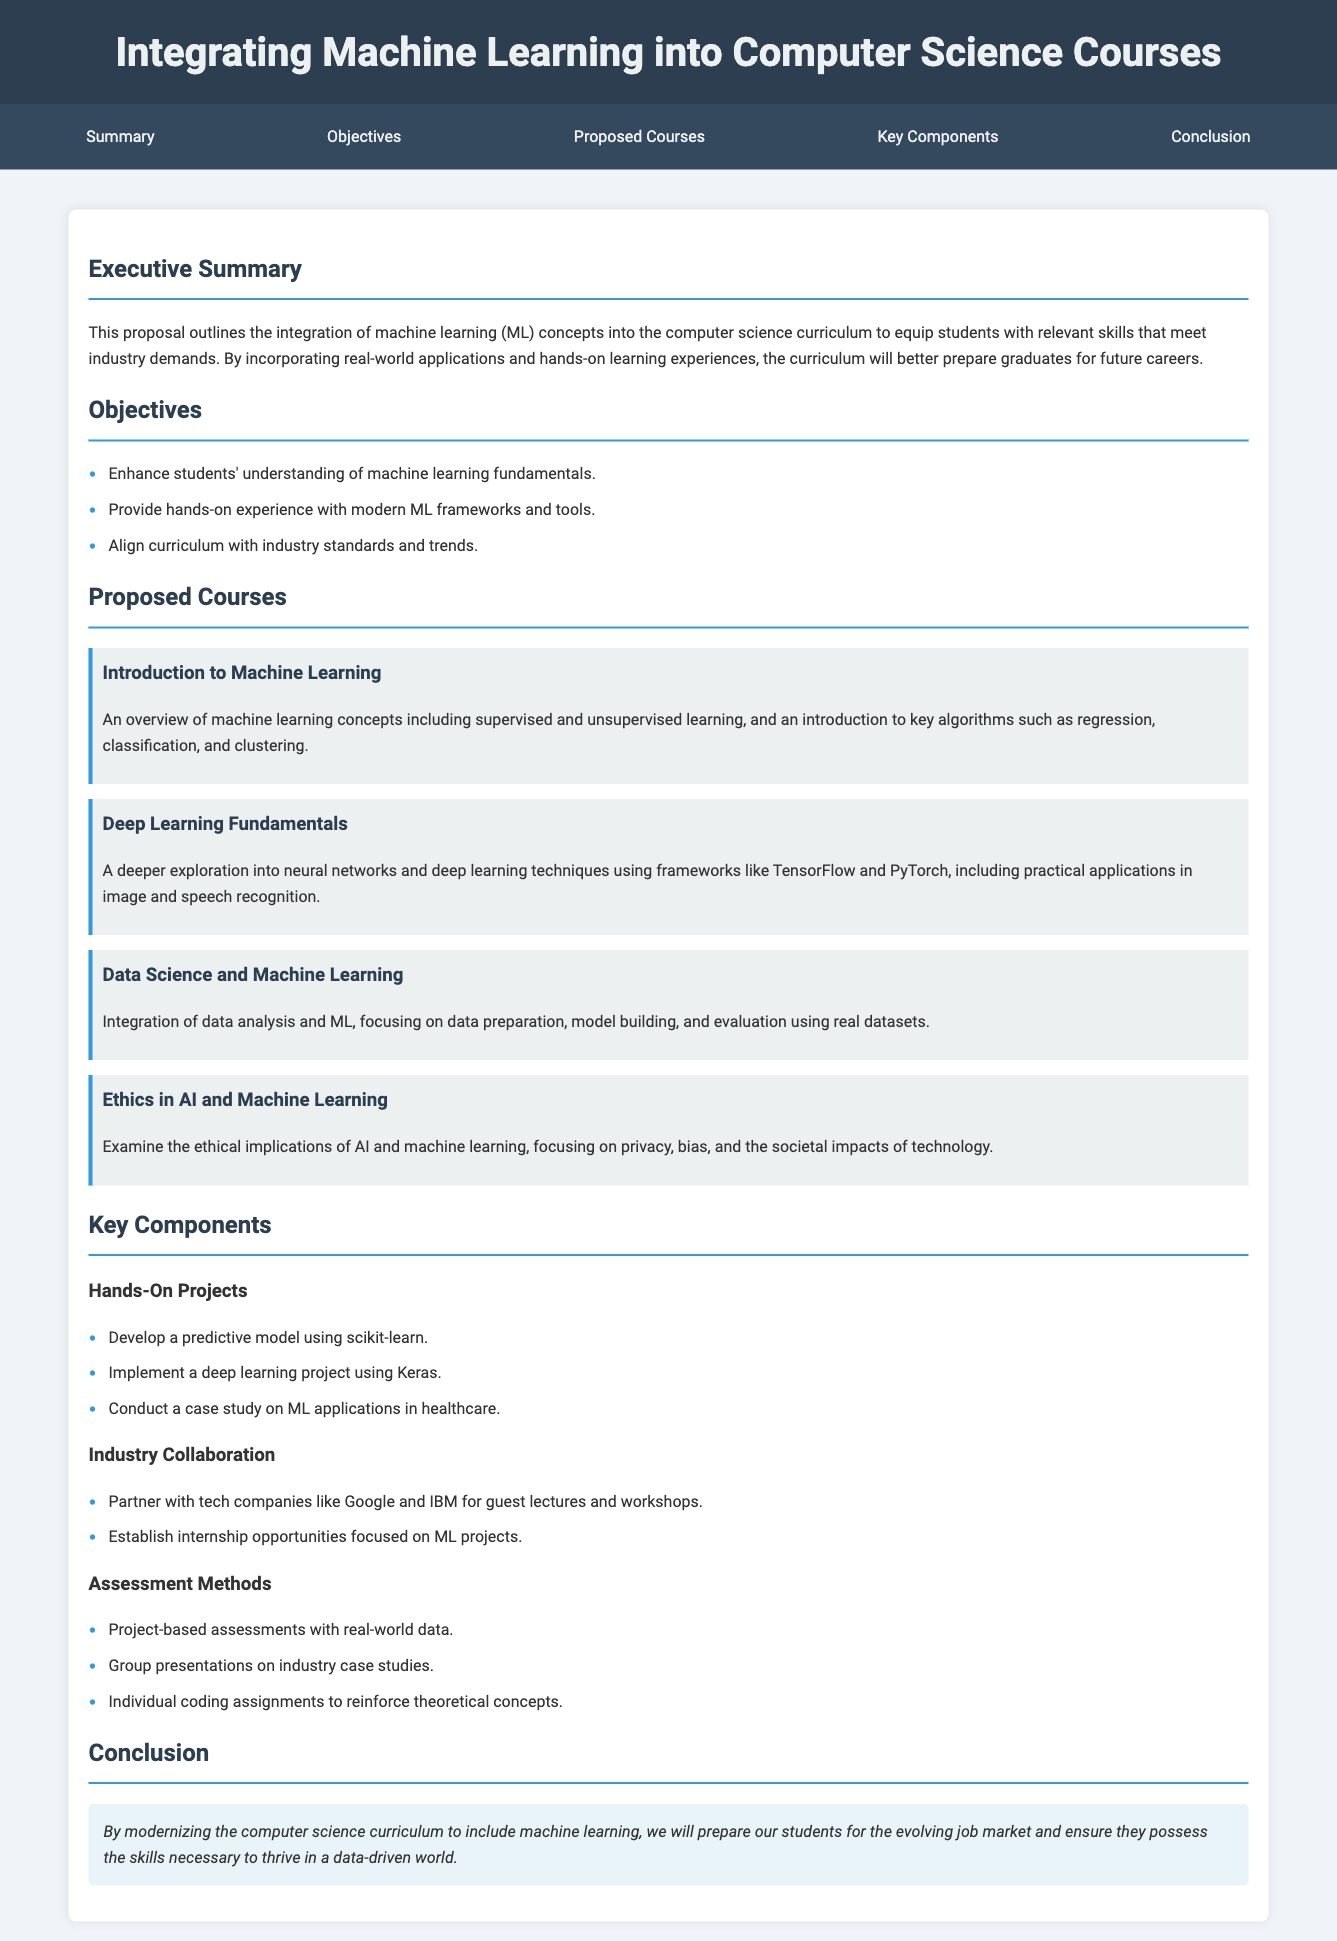What is the title of the proposal? The title of the proposal is presented in the header section of the document.
Answer: Integrating Machine Learning into Computer Science Courses What is the first objective listed? The first objective is the first item in the list of objectives in the document.
Answer: Enhance students' understanding of machine learning fundamentals How many proposed courses are mentioned? The number of proposed courses can be counted from the courses section of the document.
Answer: Four What framework is introduced in the Deep Learning Fundamentals course? The Deep Learning Fundamentals course mentions specific frameworks used in teaching.
Answer: TensorFlow and PyTorch What are the key components related to hands-on projects? The hands-on projects are listed under the key components section, which provides specific examples.
Answer: Develop a predictive model using scikit-learn What type of assessments are included? The assessment methods section outlines specific assessment types.
Answer: Project-based assessments with real-world data What is discussed in the Ethics in AI and Machine Learning course? The course's focus area is described in its summary within the courses section.
Answer: Ethical implications of AI and machine learning What is the main goal of the curriculum modernization? The conclusion summarizes the overall aim of the proposal.
Answer: Prepare our students for the evolving job market 